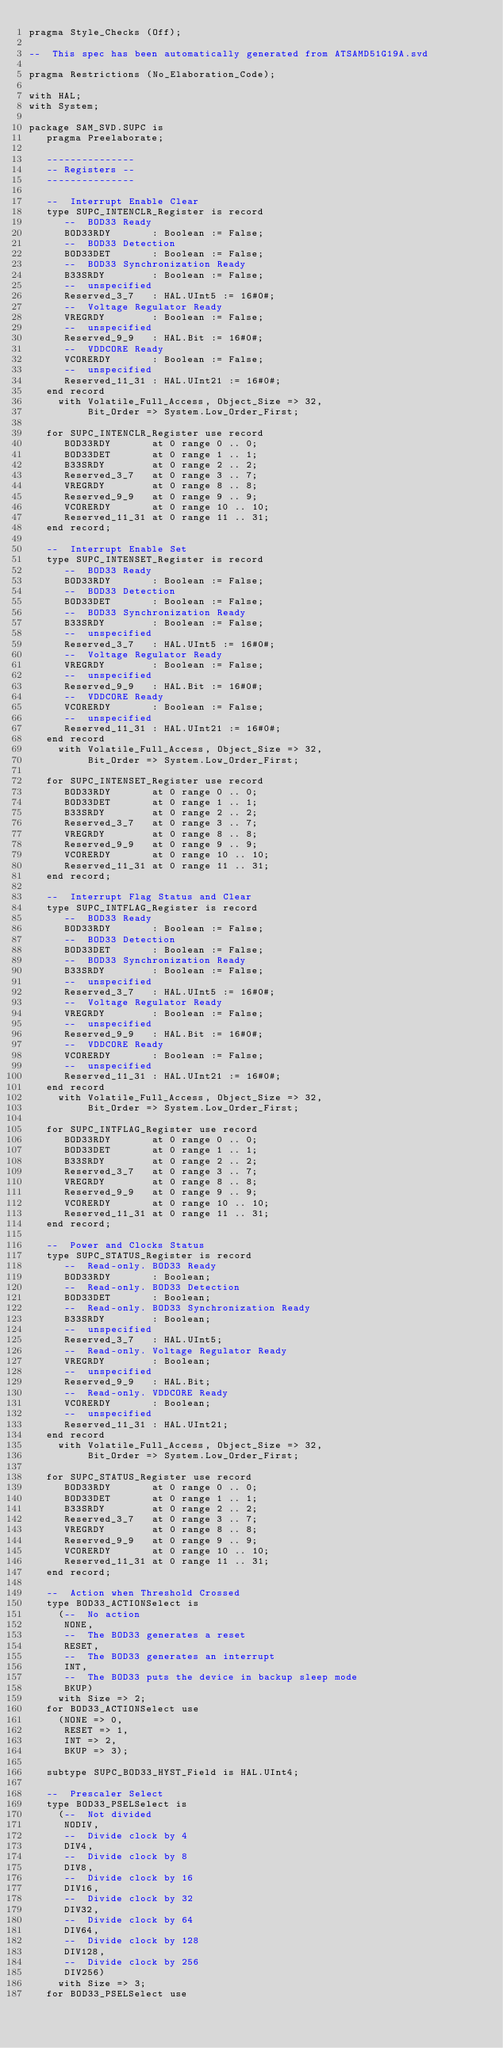<code> <loc_0><loc_0><loc_500><loc_500><_Ada_>pragma Style_Checks (Off);

--  This spec has been automatically generated from ATSAMD51G19A.svd

pragma Restrictions (No_Elaboration_Code);

with HAL;
with System;

package SAM_SVD.SUPC is
   pragma Preelaborate;

   ---------------
   -- Registers --
   ---------------

   --  Interrupt Enable Clear
   type SUPC_INTENCLR_Register is record
      --  BOD33 Ready
      BOD33RDY       : Boolean := False;
      --  BOD33 Detection
      BOD33DET       : Boolean := False;
      --  BOD33 Synchronization Ready
      B33SRDY        : Boolean := False;
      --  unspecified
      Reserved_3_7   : HAL.UInt5 := 16#0#;
      --  Voltage Regulator Ready
      VREGRDY        : Boolean := False;
      --  unspecified
      Reserved_9_9   : HAL.Bit := 16#0#;
      --  VDDCORE Ready
      VCORERDY       : Boolean := False;
      --  unspecified
      Reserved_11_31 : HAL.UInt21 := 16#0#;
   end record
     with Volatile_Full_Access, Object_Size => 32,
          Bit_Order => System.Low_Order_First;

   for SUPC_INTENCLR_Register use record
      BOD33RDY       at 0 range 0 .. 0;
      BOD33DET       at 0 range 1 .. 1;
      B33SRDY        at 0 range 2 .. 2;
      Reserved_3_7   at 0 range 3 .. 7;
      VREGRDY        at 0 range 8 .. 8;
      Reserved_9_9   at 0 range 9 .. 9;
      VCORERDY       at 0 range 10 .. 10;
      Reserved_11_31 at 0 range 11 .. 31;
   end record;

   --  Interrupt Enable Set
   type SUPC_INTENSET_Register is record
      --  BOD33 Ready
      BOD33RDY       : Boolean := False;
      --  BOD33 Detection
      BOD33DET       : Boolean := False;
      --  BOD33 Synchronization Ready
      B33SRDY        : Boolean := False;
      --  unspecified
      Reserved_3_7   : HAL.UInt5 := 16#0#;
      --  Voltage Regulator Ready
      VREGRDY        : Boolean := False;
      --  unspecified
      Reserved_9_9   : HAL.Bit := 16#0#;
      --  VDDCORE Ready
      VCORERDY       : Boolean := False;
      --  unspecified
      Reserved_11_31 : HAL.UInt21 := 16#0#;
   end record
     with Volatile_Full_Access, Object_Size => 32,
          Bit_Order => System.Low_Order_First;

   for SUPC_INTENSET_Register use record
      BOD33RDY       at 0 range 0 .. 0;
      BOD33DET       at 0 range 1 .. 1;
      B33SRDY        at 0 range 2 .. 2;
      Reserved_3_7   at 0 range 3 .. 7;
      VREGRDY        at 0 range 8 .. 8;
      Reserved_9_9   at 0 range 9 .. 9;
      VCORERDY       at 0 range 10 .. 10;
      Reserved_11_31 at 0 range 11 .. 31;
   end record;

   --  Interrupt Flag Status and Clear
   type SUPC_INTFLAG_Register is record
      --  BOD33 Ready
      BOD33RDY       : Boolean := False;
      --  BOD33 Detection
      BOD33DET       : Boolean := False;
      --  BOD33 Synchronization Ready
      B33SRDY        : Boolean := False;
      --  unspecified
      Reserved_3_7   : HAL.UInt5 := 16#0#;
      --  Voltage Regulator Ready
      VREGRDY        : Boolean := False;
      --  unspecified
      Reserved_9_9   : HAL.Bit := 16#0#;
      --  VDDCORE Ready
      VCORERDY       : Boolean := False;
      --  unspecified
      Reserved_11_31 : HAL.UInt21 := 16#0#;
   end record
     with Volatile_Full_Access, Object_Size => 32,
          Bit_Order => System.Low_Order_First;

   for SUPC_INTFLAG_Register use record
      BOD33RDY       at 0 range 0 .. 0;
      BOD33DET       at 0 range 1 .. 1;
      B33SRDY        at 0 range 2 .. 2;
      Reserved_3_7   at 0 range 3 .. 7;
      VREGRDY        at 0 range 8 .. 8;
      Reserved_9_9   at 0 range 9 .. 9;
      VCORERDY       at 0 range 10 .. 10;
      Reserved_11_31 at 0 range 11 .. 31;
   end record;

   --  Power and Clocks Status
   type SUPC_STATUS_Register is record
      --  Read-only. BOD33 Ready
      BOD33RDY       : Boolean;
      --  Read-only. BOD33 Detection
      BOD33DET       : Boolean;
      --  Read-only. BOD33 Synchronization Ready
      B33SRDY        : Boolean;
      --  unspecified
      Reserved_3_7   : HAL.UInt5;
      --  Read-only. Voltage Regulator Ready
      VREGRDY        : Boolean;
      --  unspecified
      Reserved_9_9   : HAL.Bit;
      --  Read-only. VDDCORE Ready
      VCORERDY       : Boolean;
      --  unspecified
      Reserved_11_31 : HAL.UInt21;
   end record
     with Volatile_Full_Access, Object_Size => 32,
          Bit_Order => System.Low_Order_First;

   for SUPC_STATUS_Register use record
      BOD33RDY       at 0 range 0 .. 0;
      BOD33DET       at 0 range 1 .. 1;
      B33SRDY        at 0 range 2 .. 2;
      Reserved_3_7   at 0 range 3 .. 7;
      VREGRDY        at 0 range 8 .. 8;
      Reserved_9_9   at 0 range 9 .. 9;
      VCORERDY       at 0 range 10 .. 10;
      Reserved_11_31 at 0 range 11 .. 31;
   end record;

   --  Action when Threshold Crossed
   type BOD33_ACTIONSelect is
     (--  No action
      NONE,
      --  The BOD33 generates a reset
      RESET,
      --  The BOD33 generates an interrupt
      INT,
      --  The BOD33 puts the device in backup sleep mode
      BKUP)
     with Size => 2;
   for BOD33_ACTIONSelect use
     (NONE => 0,
      RESET => 1,
      INT => 2,
      BKUP => 3);

   subtype SUPC_BOD33_HYST_Field is HAL.UInt4;

   --  Prescaler Select
   type BOD33_PSELSelect is
     (--  Not divided
      NODIV,
      --  Divide clock by 4
      DIV4,
      --  Divide clock by 8
      DIV8,
      --  Divide clock by 16
      DIV16,
      --  Divide clock by 32
      DIV32,
      --  Divide clock by 64
      DIV64,
      --  Divide clock by 128
      DIV128,
      --  Divide clock by 256
      DIV256)
     with Size => 3;
   for BOD33_PSELSelect use</code> 